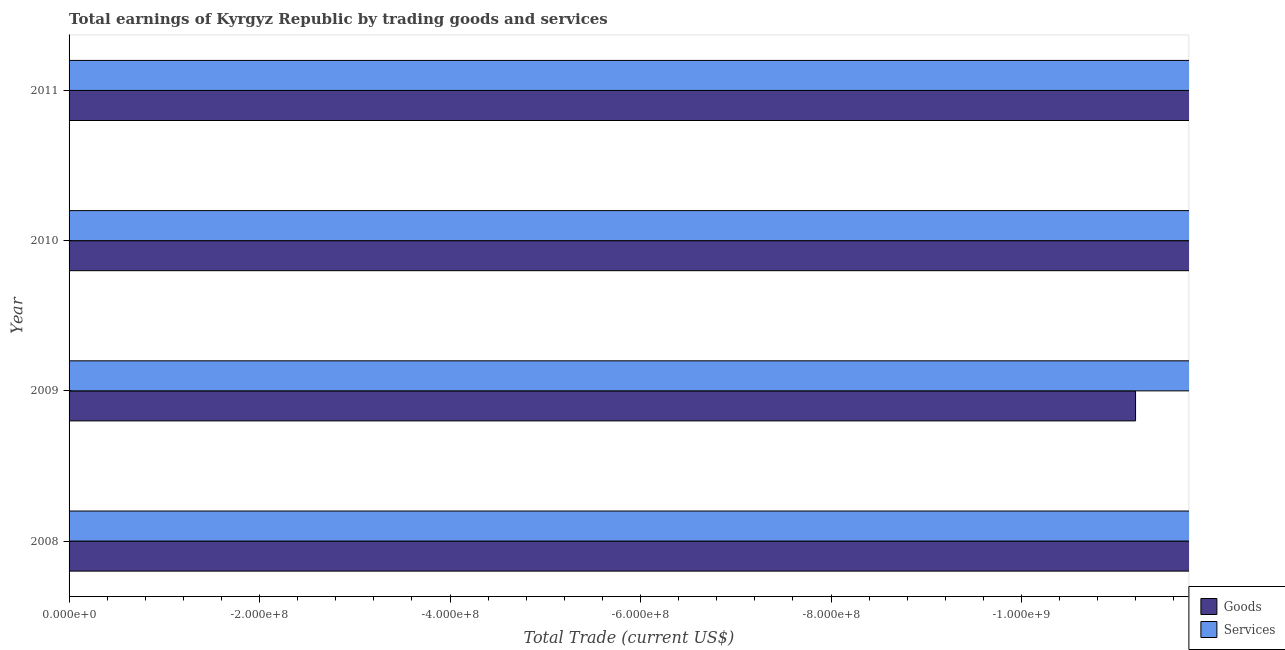Are the number of bars on each tick of the Y-axis equal?
Ensure brevity in your answer.  Yes. What is the label of the 4th group of bars from the top?
Ensure brevity in your answer.  2008. Across all years, what is the minimum amount earned by trading goods?
Offer a very short reply. 0. What is the total amount earned by trading goods in the graph?
Your response must be concise. 0. What is the average amount earned by trading goods per year?
Offer a very short reply. 0. Are all the bars in the graph horizontal?
Your response must be concise. Yes. What is the difference between two consecutive major ticks on the X-axis?
Ensure brevity in your answer.  2.00e+08. Does the graph contain any zero values?
Ensure brevity in your answer.  Yes. How many legend labels are there?
Give a very brief answer. 2. What is the title of the graph?
Provide a succinct answer. Total earnings of Kyrgyz Republic by trading goods and services. Does "IMF concessional" appear as one of the legend labels in the graph?
Your answer should be very brief. No. What is the label or title of the X-axis?
Give a very brief answer. Total Trade (current US$). What is the Total Trade (current US$) of Services in 2008?
Offer a terse response. 0. What is the Total Trade (current US$) in Goods in 2009?
Give a very brief answer. 0. What is the Total Trade (current US$) in Services in 2010?
Keep it short and to the point. 0. What is the total Total Trade (current US$) of Services in the graph?
Your response must be concise. 0. What is the average Total Trade (current US$) of Services per year?
Your answer should be very brief. 0. 